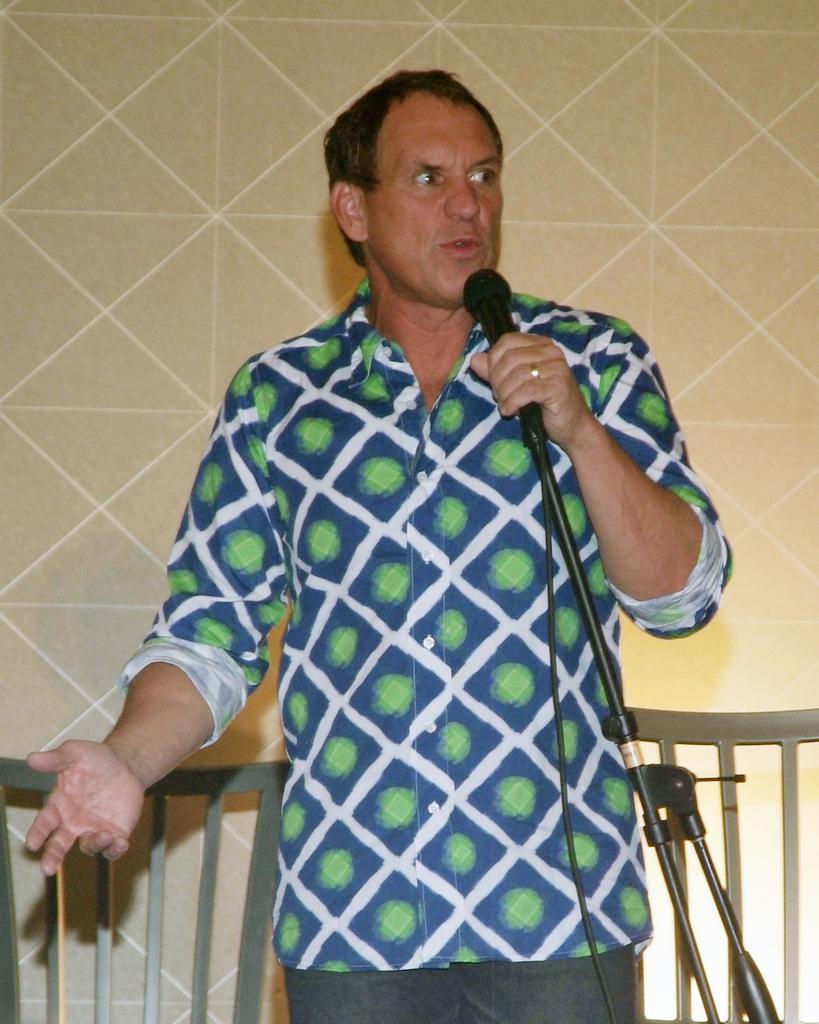Can you describe this image briefly? In this picture there is a person standing and holding microphone. There is microphone with stand. In this background we can see wall and we can see chairs. 